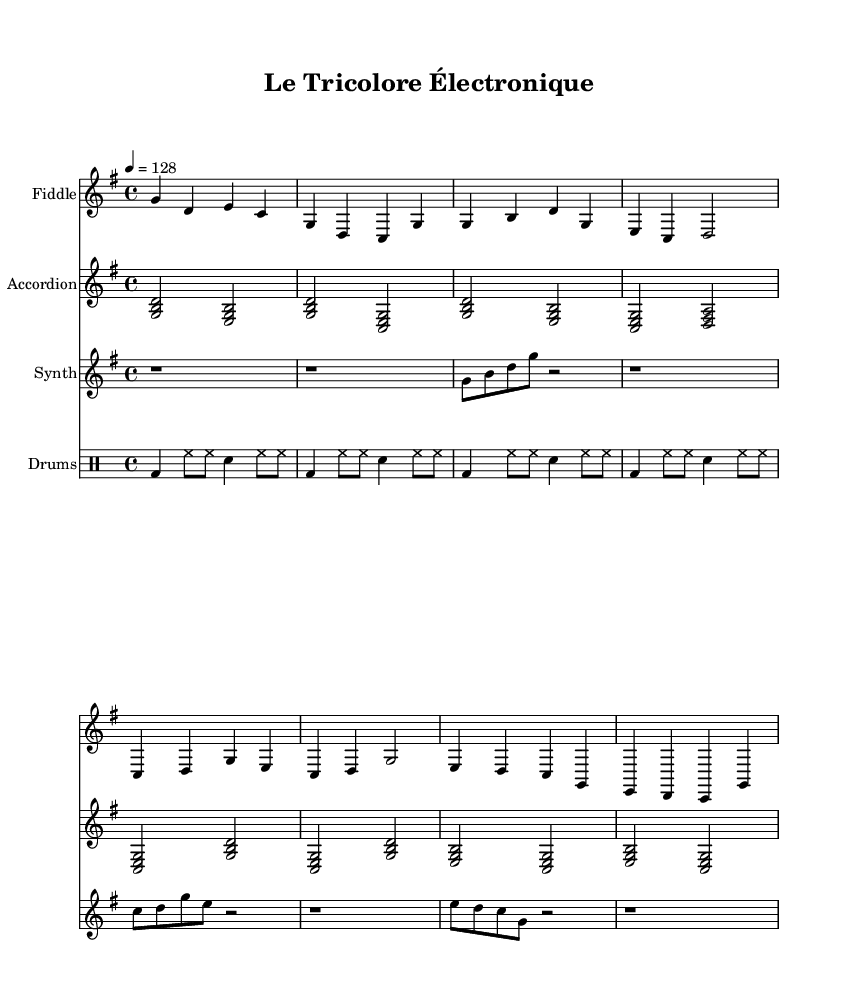What is the key signature of this music? The key signature is G major, which has one sharp (F#).
Answer: G major What is the time signature of this piece? The time signature is 4/4, indicating four beats per measure.
Answer: 4/4 What is the tempo marking for this music? The tempo marking is quarter note equals 128 beats per minute.
Answer: 128 What instruments are included in this score? The score includes fiddle, accordion, synthesizer, and drums.
Answer: Fiddle, accordion, synthesizer, drums How many measures are present in the intro section? The intro consists of 2 measures as indicated by the grouping of notes.
Answer: 2 measures In the chorus, which notes are played by the fiddle? The fiddle plays notes C, D, G, E in the chorus section.
Answer: C, D, G, E What type of rhythm pattern do the drums follow? The drums follow a basic four-on-the-floor rhythm pattern with hi-hat.
Answer: Four-on-the-floor 